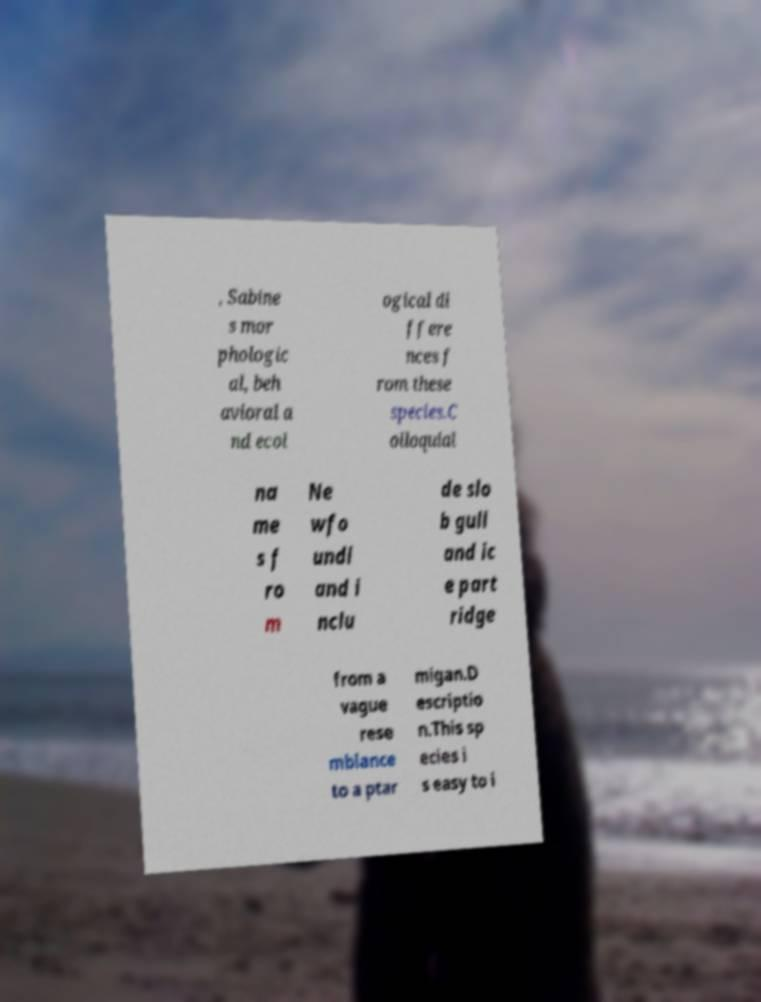I need the written content from this picture converted into text. Can you do that? , Sabine s mor phologic al, beh avioral a nd ecol ogical di ffere nces f rom these species.C olloquial na me s f ro m Ne wfo undl and i nclu de slo b gull and ic e part ridge from a vague rese mblance to a ptar migan.D escriptio n.This sp ecies i s easy to i 